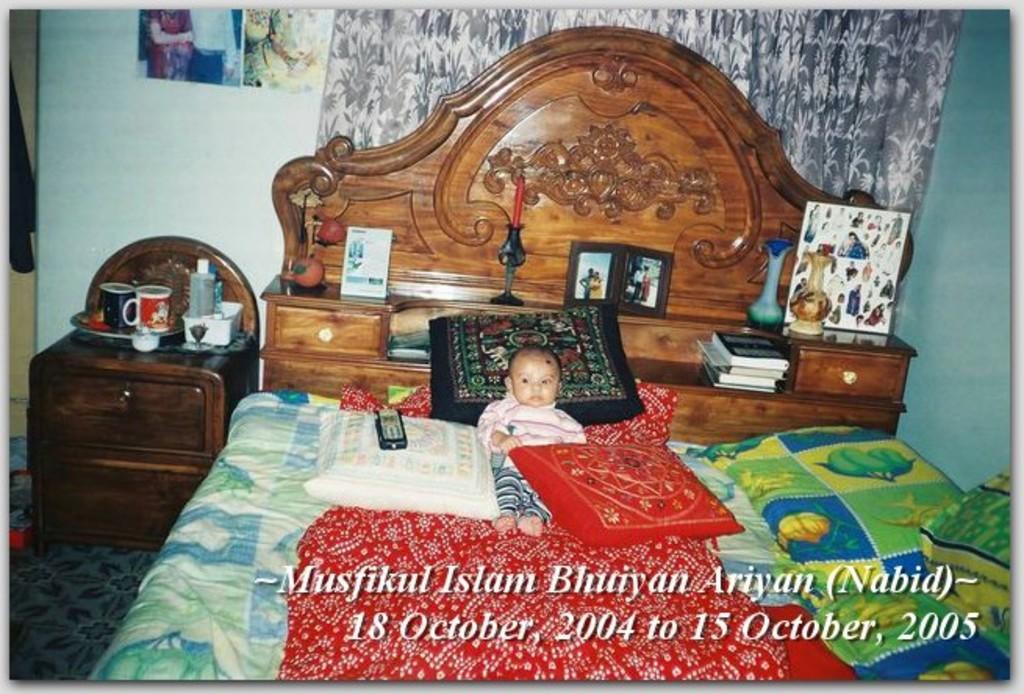Describe this image in one or two sentences. In the center we can see baby sleeping on the bed and beside the bed there is a table. And coming to the background there is a wall. 